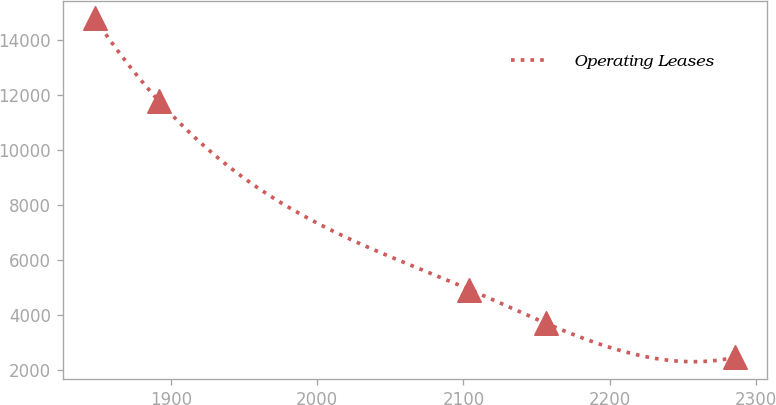<chart> <loc_0><loc_0><loc_500><loc_500><line_chart><ecel><fcel>Operating Leases<nl><fcel>1847.85<fcel>14784.4<nl><fcel>1891.64<fcel>11781.3<nl><fcel>2104.13<fcel>4926.62<nl><fcel>2156.71<fcel>3694.41<nl><fcel>2285.76<fcel>2462.2<nl></chart> 